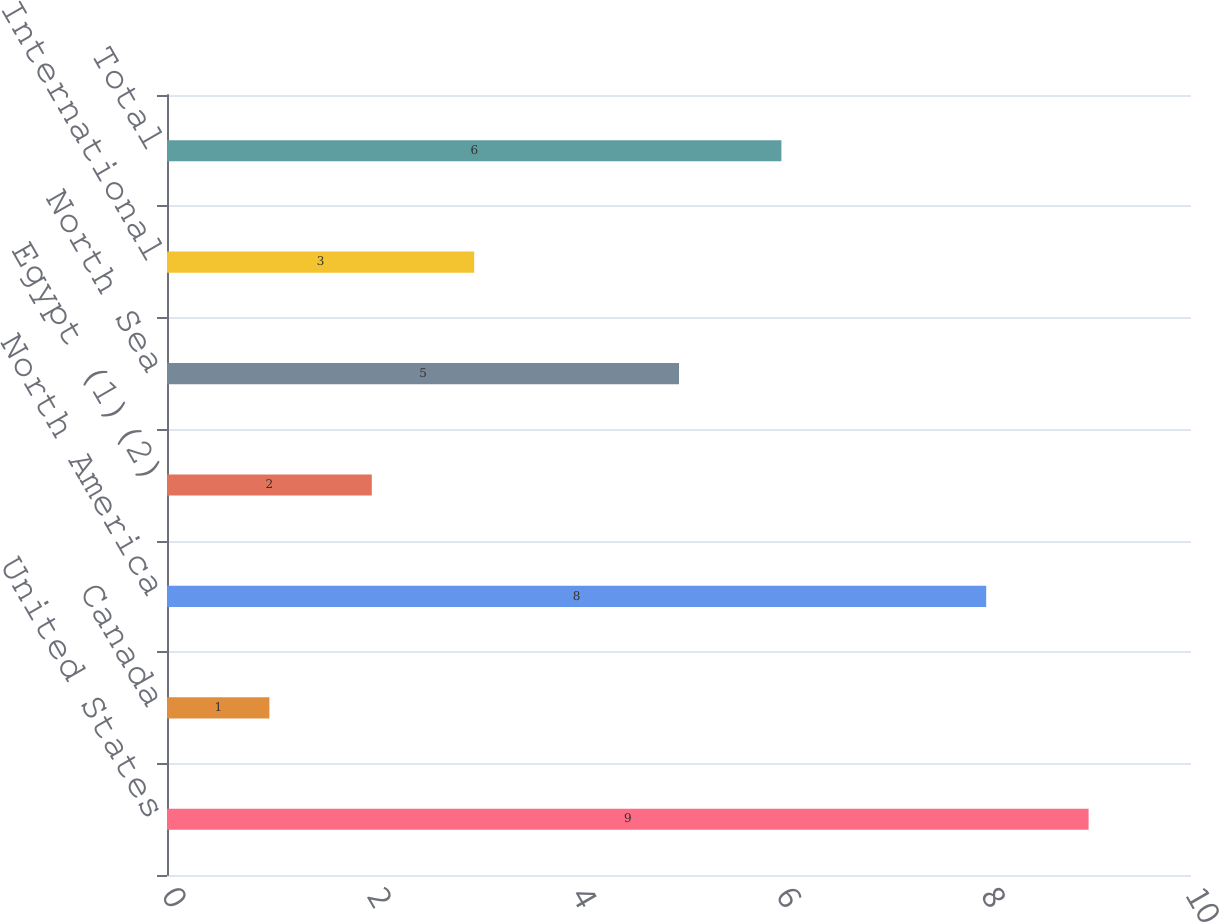<chart> <loc_0><loc_0><loc_500><loc_500><bar_chart><fcel>United States<fcel>Canada<fcel>North America<fcel>Egypt (1)(2)<fcel>North Sea<fcel>International<fcel>Total<nl><fcel>9<fcel>1<fcel>8<fcel>2<fcel>5<fcel>3<fcel>6<nl></chart> 